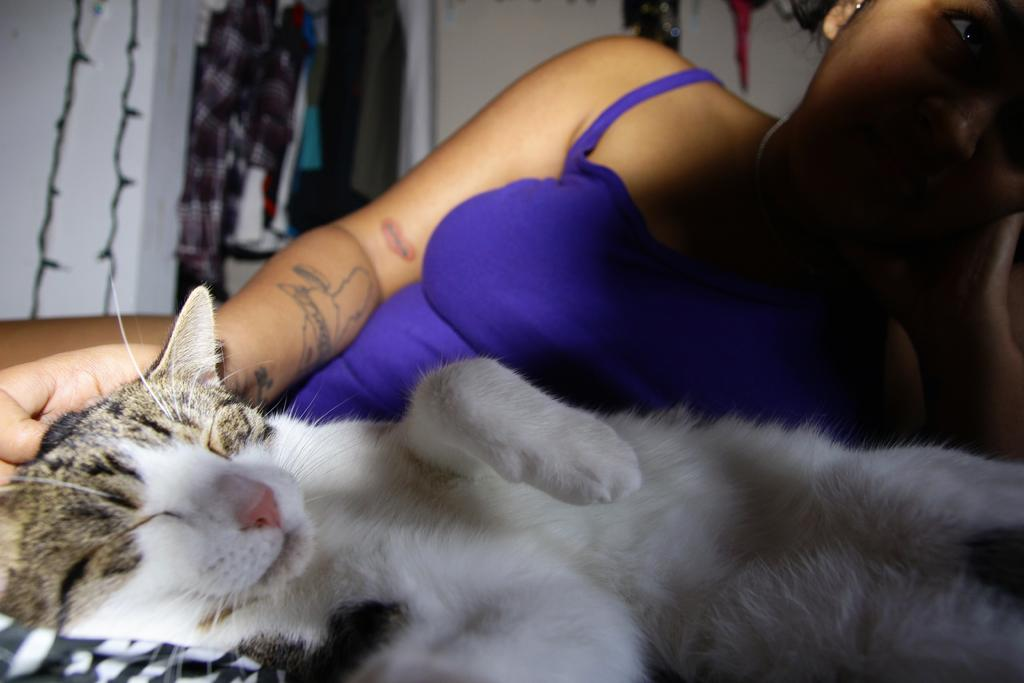What is present in the image? There is a woman and a cat in the image. Can you describe the woman's clothing in the image? The woman is wearing a blue top. What type of silk is the woman using to aid her digestion in the image? There is no silk or reference to digestion in the image; the woman is simply wearing a blue top. 